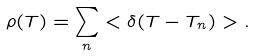<formula> <loc_0><loc_0><loc_500><loc_500>\rho ( T ) = \sum _ { n } < \delta ( T - T _ { n } ) > .</formula> 